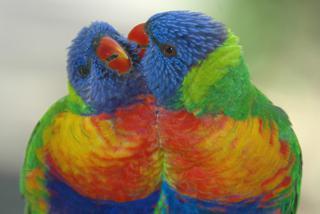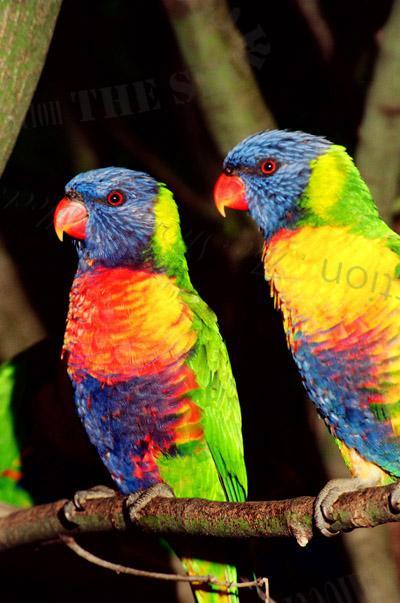The first image is the image on the left, the second image is the image on the right. Considering the images on both sides, is "Four colorful birds are perched outside." valid? Answer yes or no. Yes. The first image is the image on the left, the second image is the image on the right. Assess this claim about the two images: "Exactly four parrots are shown, one pair of similar coloring in each image, with one pair in or near vegetation.". Correct or not? Answer yes or no. Yes. 